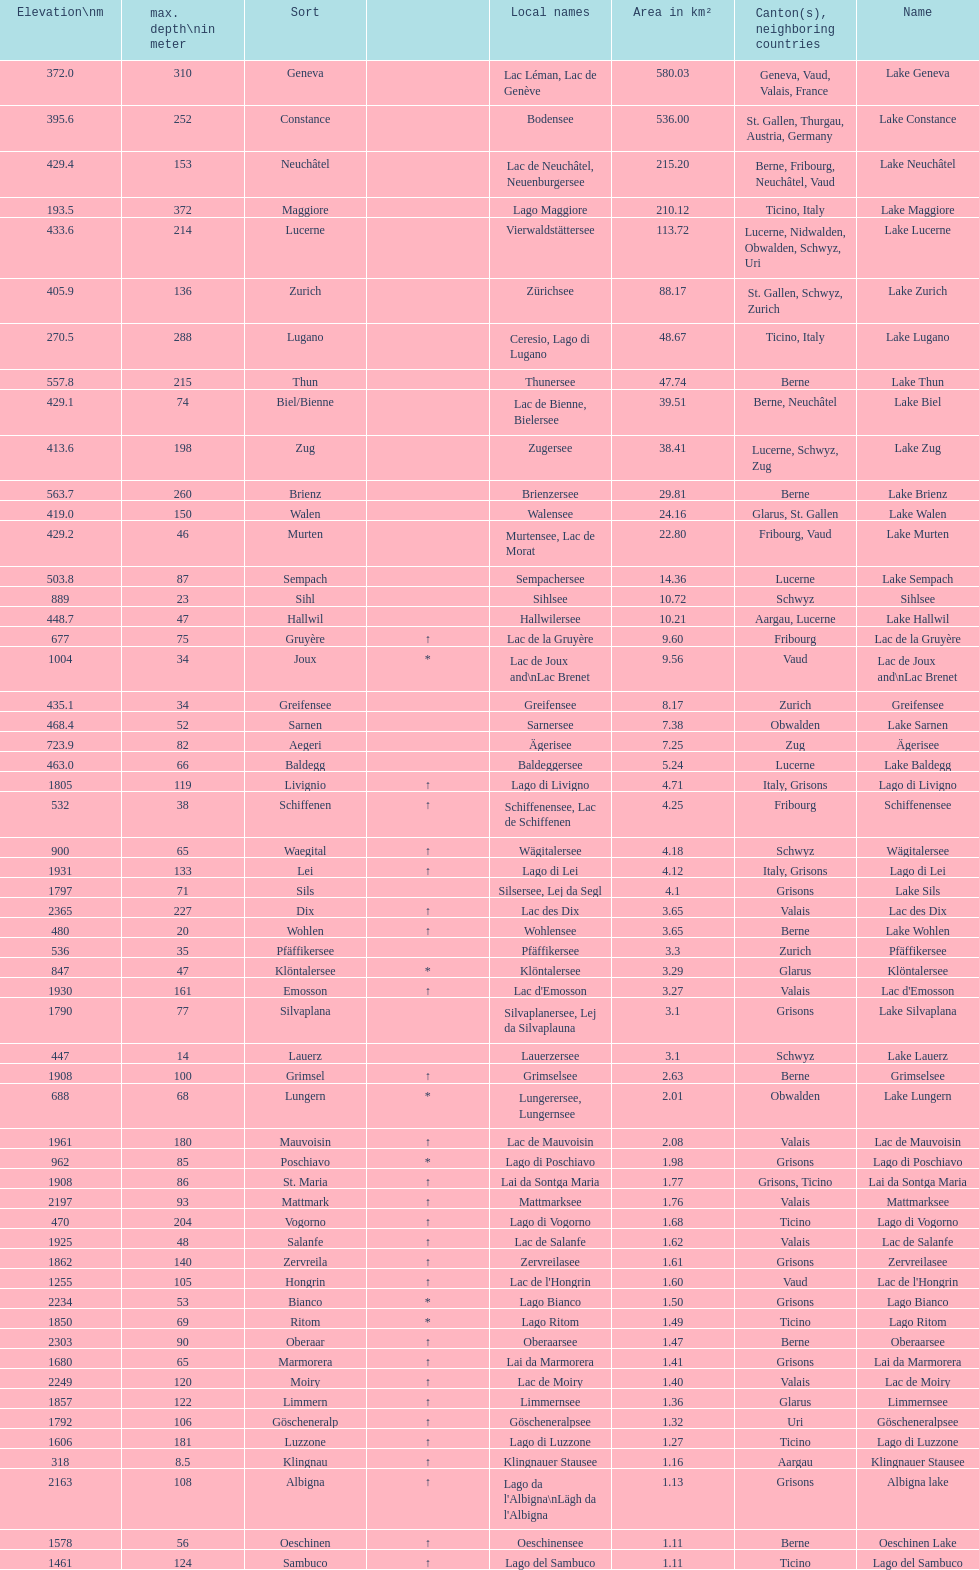Which is the only lake with a max depth of 372m? Lake Maggiore. 